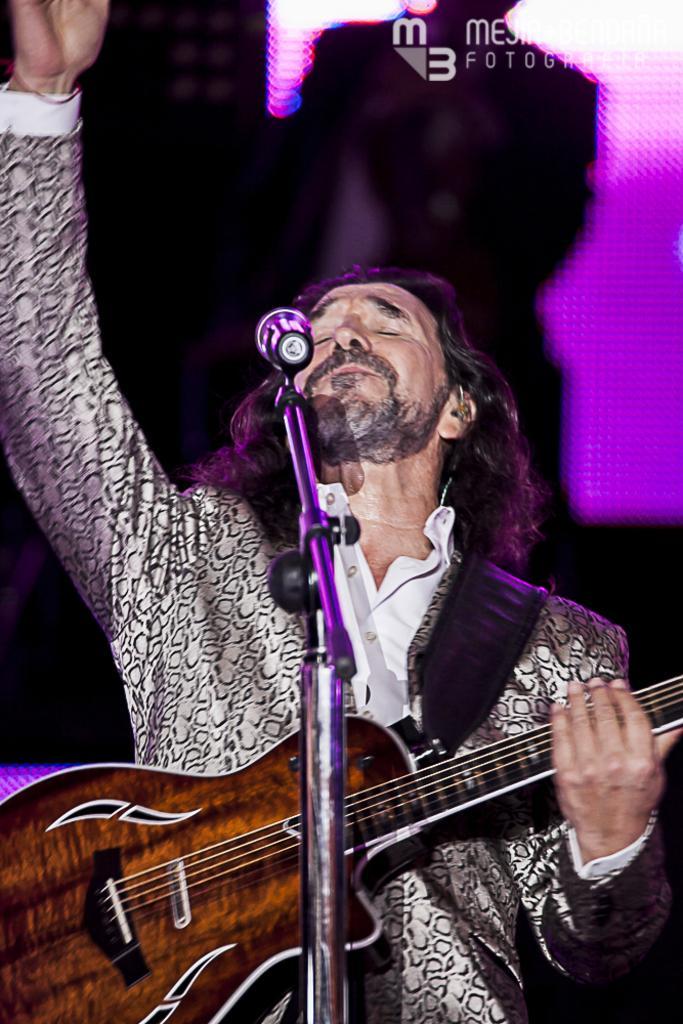Could you give a brief overview of what you see in this image? In this image, In the middle there is a man who is holding a music instrument which is in brown color, There is a microphone he is singing in microphone. 